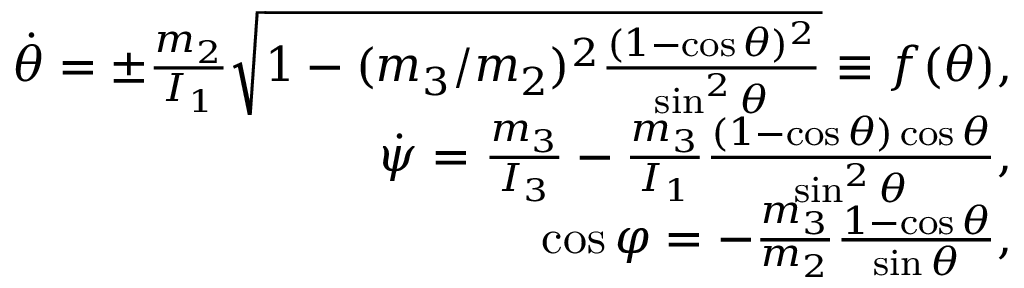Convert formula to latex. <formula><loc_0><loc_0><loc_500><loc_500>\begin{array} { r } { \dot { \theta } = \pm \frac { m _ { 2 } } { I _ { 1 } } \sqrt { 1 - ( m _ { 3 } / m _ { 2 } ) ^ { 2 } \frac { ( 1 - \cos \theta ) ^ { 2 } } { \sin ^ { 2 } \theta } } \equiv f ( \theta ) , } \\ { \dot { \psi } = \frac { m _ { 3 } } { I _ { 3 } } - \frac { m _ { 3 } } { I _ { 1 } } \frac { ( 1 - \cos \theta ) \cos \theta } { \sin ^ { 2 } \theta } , } \\ { \cos \varphi = - \frac { m _ { 3 } } { m _ { 2 } } \frac { 1 - \cos \theta } { \sin \theta } , } \end{array}</formula> 